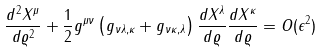Convert formula to latex. <formula><loc_0><loc_0><loc_500><loc_500>\frac { d ^ { 2 } X ^ { \mu } } { d \varrho ^ { 2 } } + \frac { 1 } { 2 } g ^ { \mu \nu } \left ( g _ { \nu \lambda , \kappa } + g _ { \nu \kappa , \lambda } \right ) \frac { d X ^ { \lambda } } { d \varrho } \frac { d X ^ { \kappa } } { d \varrho } = O ( \epsilon ^ { 2 } )</formula> 